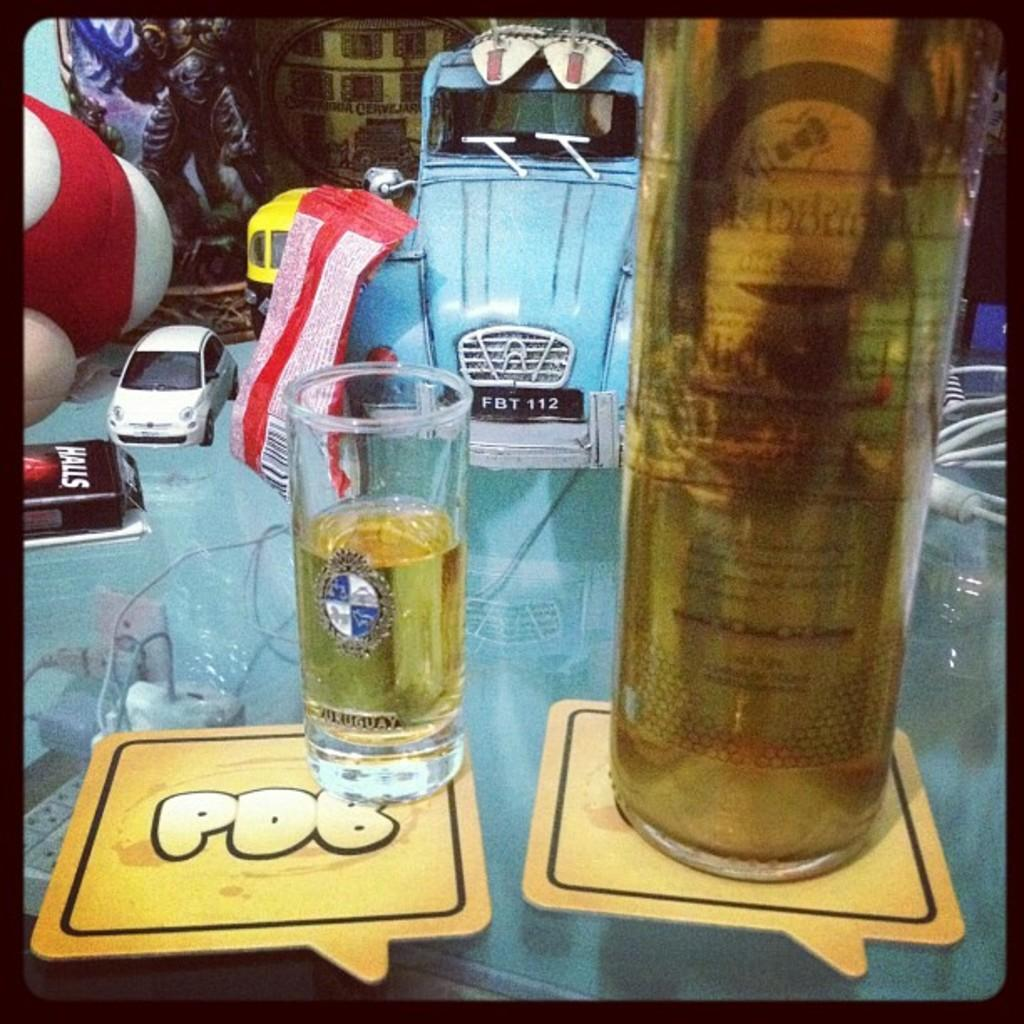<image>
Render a clear and concise summary of the photo. A small glass of liquid sitting on top of a coaster with the letters PDB written on it. 